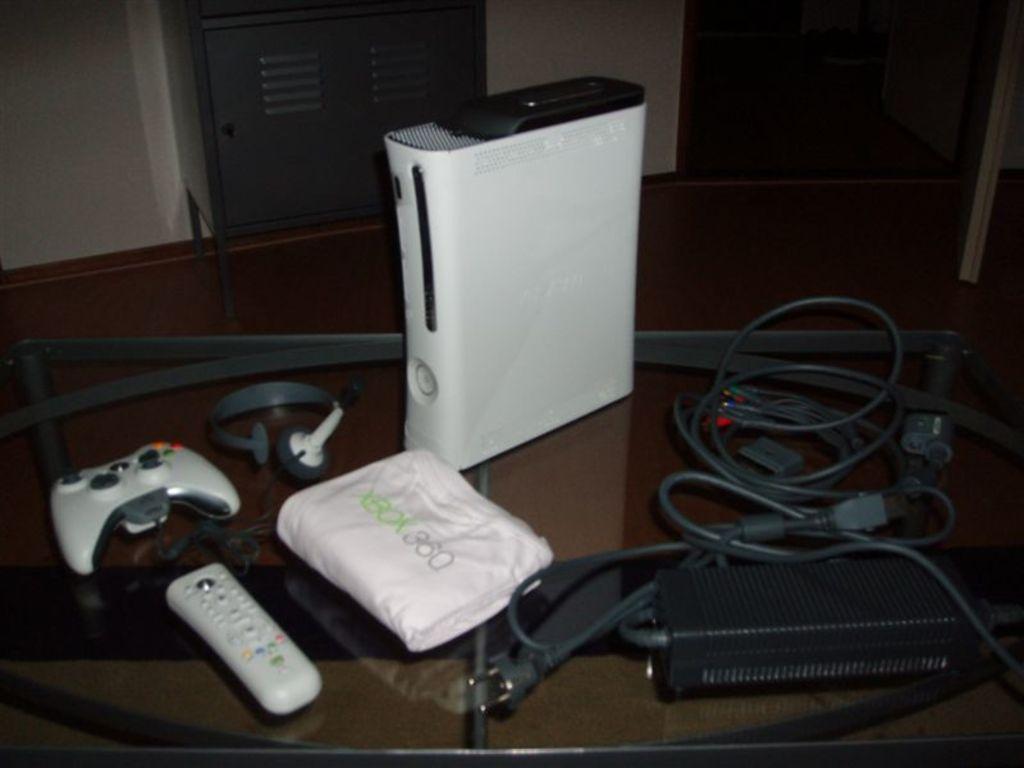What is the video game system?
Provide a short and direct response. Xbox 360. What is the name of this gaming system?
Your response must be concise. Xbox 360. 